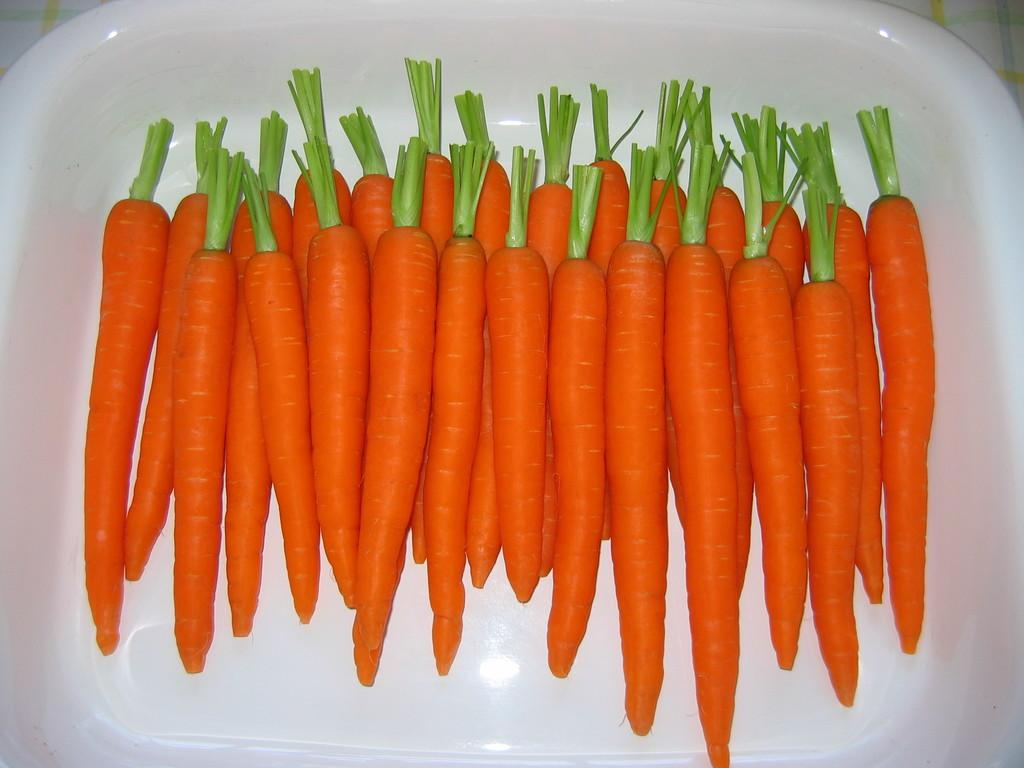What type of vegetable is present in the image? There are carrots in the image. In what type of container are the carrots placed? The carrots are in a white color bowl. What type of base is used for the guitar on the stage in the image? There is no guitar or stage present in the image; it only features carrots in a white color bowl. 